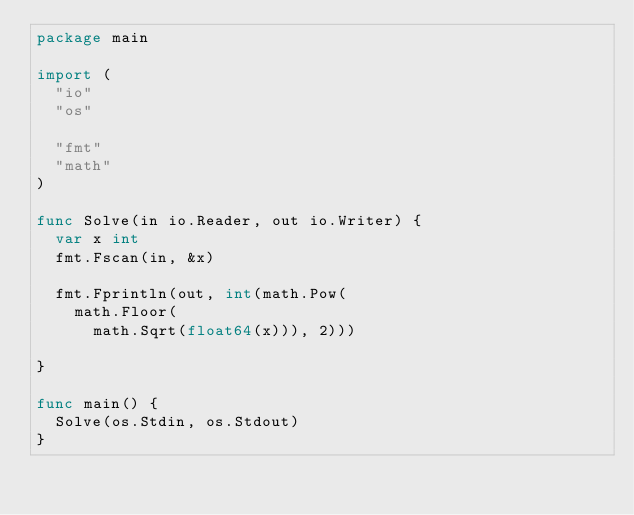<code> <loc_0><loc_0><loc_500><loc_500><_Go_>package main

import (
	"io"
	"os"

	"fmt"
	"math"
)

func Solve(in io.Reader, out io.Writer) {
	var x int
	fmt.Fscan(in, &x)

	fmt.Fprintln(out, int(math.Pow(
		math.Floor(
			math.Sqrt(float64(x))), 2)))

}

func main() {
	Solve(os.Stdin, os.Stdout)
}
</code> 